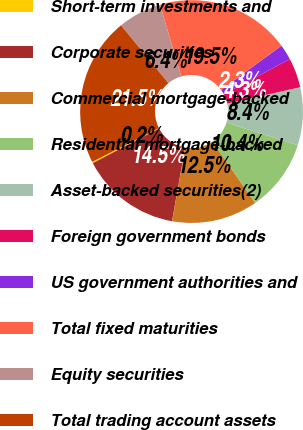<chart> <loc_0><loc_0><loc_500><loc_500><pie_chart><fcel>Short-term investments and<fcel>Corporate securities<fcel>Commercial mortgage-backed<fcel>Residential mortgage-backed<fcel>Asset-backed securities(2)<fcel>Foreign government bonds<fcel>US government authorities and<fcel>Total fixed maturities<fcel>Equity securities<fcel>Total trading account assets<nl><fcel>0.21%<fcel>14.53%<fcel>12.48%<fcel>10.44%<fcel>8.39%<fcel>4.3%<fcel>2.26%<fcel>19.5%<fcel>6.35%<fcel>21.54%<nl></chart> 